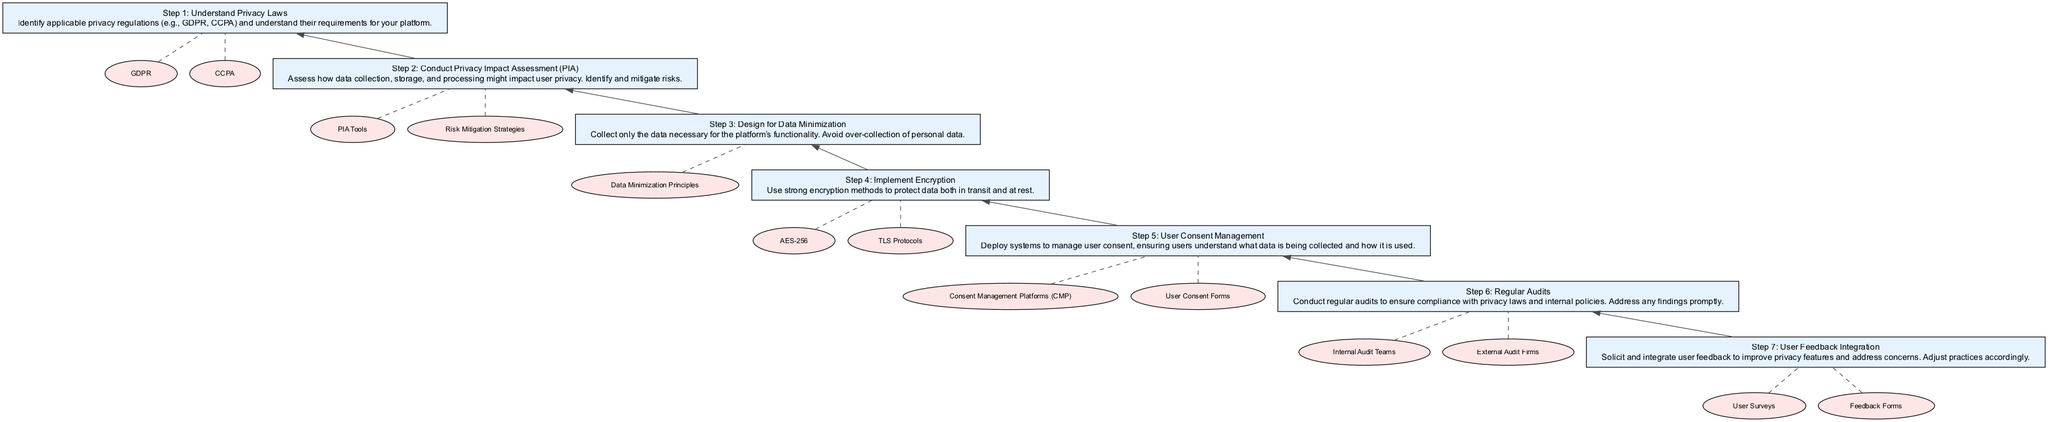What is the first step in the diagram? The first step is listed at the bottom of the diagram, which is "Understand Privacy Laws". This is the foundational step before proceeding to other actions.
Answer: Understand Privacy Laws How many steps are displayed in the diagram? There are a total of seven steps shown in the flow chart. Each step represents a crucial action in implementing privacy-first features.
Answer: 7 What is the last step in the flow? The last step is "User Feedback Integration", which is focused on soliciting user feedback to enhance privacy features. It's at the top of the flow chart.
Answer: User Feedback Integration Which step involves managing user consent? "User Consent Management" specifically addresses how to deploy systems to manage user consent regarding data collection and usage.
Answer: User Consent Management What is the relationship between "Conduct Privacy Impact Assessment (PIA)" and "Regular Audits"? "Conduct Privacy Impact Assessment (PIA)" is connected to "Regular Audits" in that the PIA helps identify risks that should be checked during audits. Regular audits ensure compliance based on the findings of such assessments.
Answer: Assessment informs audits What entities are associated with the step "Implement Encryption"? Two entities are associated with this step: "AES-256" and "TLS Protocols". These are specific encryption methods used to secure data.
Answer: AES-256, TLS Protocols What specific action is taken during the "Design for Data Minimization" step? The action is to "Collect only the data necessary for the platform’s functionality". This emphasizes the principle of minimizing data collection to what is essential for operation.
Answer: Collect only necessary data Which two tools are mentioned for conducting a Privacy Impact Assessment? The tools mentioned for conducting a PIA are "PIA Tools" and "Risk Mitigation Strategies". These assist in assessing risks involved with data handling.
Answer: PIA Tools, Risk Mitigation Strategies How does "User Feedback Integration" relate to the previous steps? It allows for a feedback loop where user insights from earlier steps are used to refine and improve privacy features and practices in the platform.
Answer: Refines privacy features 